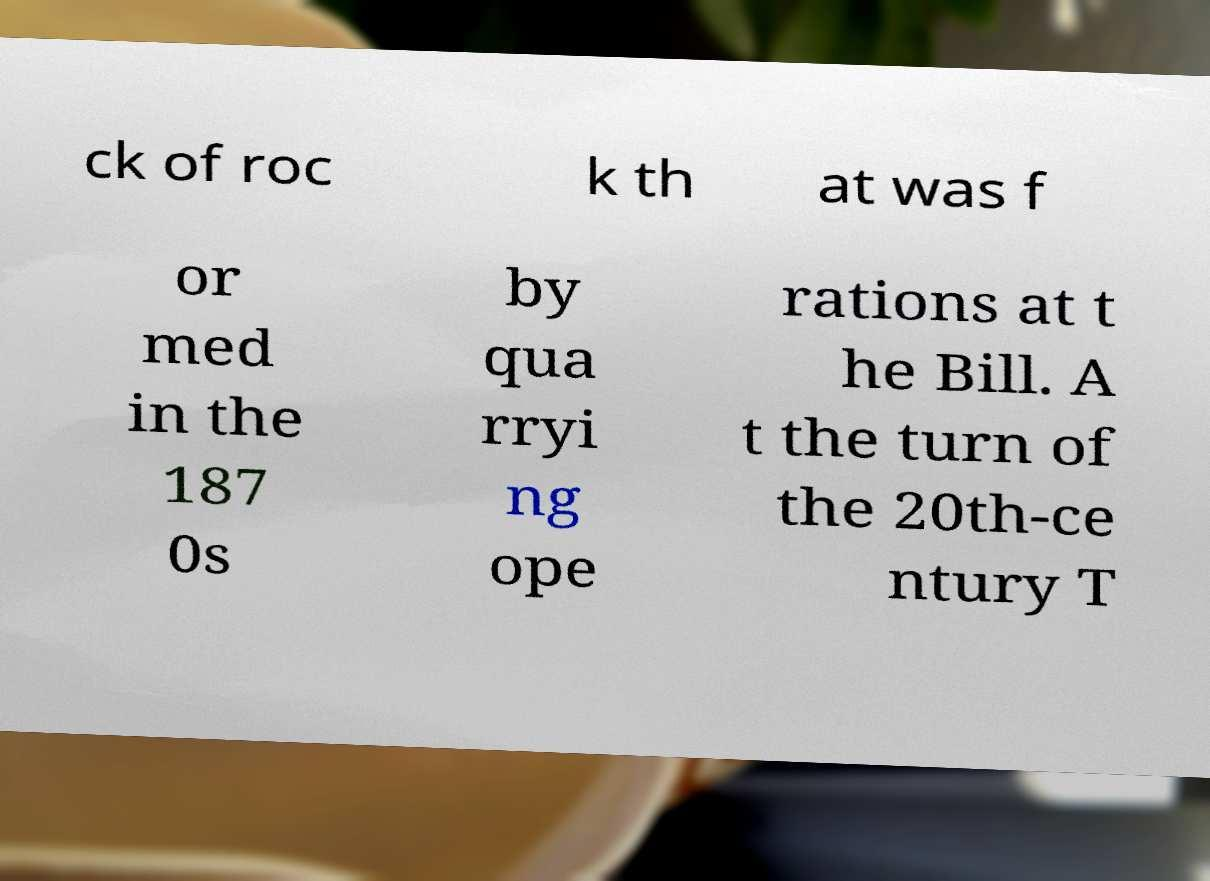Could you assist in decoding the text presented in this image and type it out clearly? ck of roc k th at was f or med in the 187 0s by qua rryi ng ope rations at t he Bill. A t the turn of the 20th-ce ntury T 